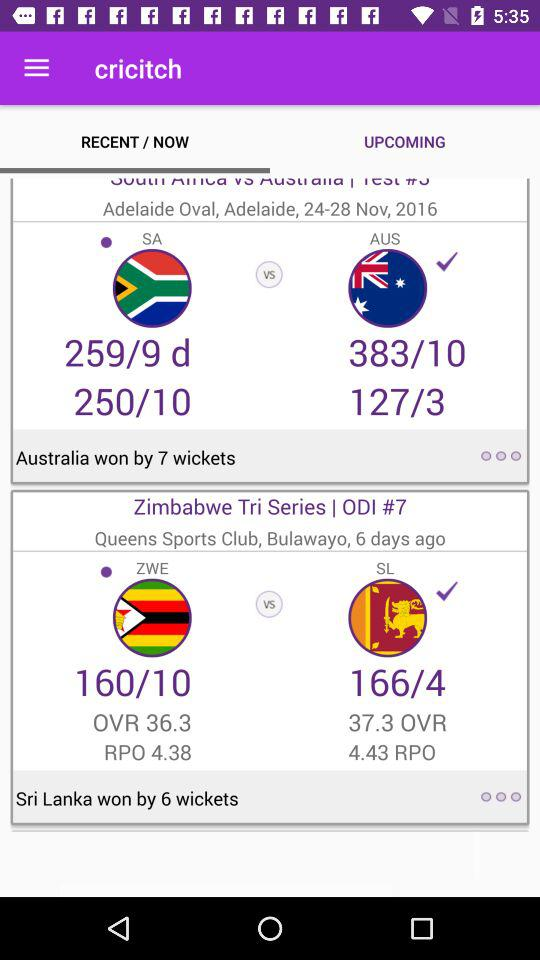By how many wickets did Sri Lanka win? Sri Lanka won by 6 wickets. 